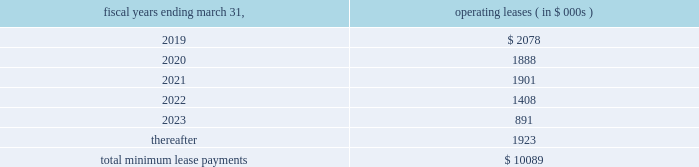Note 11 .
Commitments and contingencies commitments leases the company fffds corporate headquarters is located in danvers , massachusetts .
This facility encompasses most of the company fffds u.s .
Operations , including research and development , manufacturing , sales and marketing and general and administrative departments .
In october 2017 , the acquired its corporate headquarters for approximately $ 16.5 million and terminated its existing lease arrangement ( see note 6 ) .
Future minimum lease payments under non-cancelable leases as of march 31 , 2018 are approximately as follows : fiscal years ending march 31 , operating leases ( in $ 000s ) .
In february 2017 , the company entered into a lease agreement for an additional 21603 square feet of office space in danvers , massachusetts which expires on july 31 , 2022 .
In december 2017 , the company entered into an amendment to this lease to extend the term through august 31 , 2025 and to add an additional 6607 square feet of space in which rent would begin around june 1 , 2018 .
The amendment also allows the company a right of first offer to purchase the property from january 1 , 2018 through august 31 , 2035 , if the lessor decides to sell the building or receives an offer to purchase the building from a third-party buyer .
In march 2018 , the company entered into an amendment to the lease to add an additional 11269 square feet of space for which rent will begin on or around june 1 , 2018 through august 31 , 2025 .
The annual rent expense for this lease agreement is estimated to be $ 0.4 million .
In september 2016 , the company entered into a lease agreement in berlin , germany which commenced in may 2017 and expires in may 2024 .
The annual rent expense for the lease is estimated to be $ 0.3 million .
In october 2016 , the company entered into a lease agreement for an office in tokyokk japan and expires in september 2021 .
The office houses administrative , regulatory , and training personnel in connection with the company fffds commercial launch in japan .
The annual rent expense for the lease is estimated to be $ 0.9 million .
License agreements in april 2014 , the company entered into an exclusive license agreement for the rights to certain optical sensor technologies in the field of cardio-circulatory assist devices .
Pursuant to the terms of the license agreement , the company agreed to make potential payments of $ 6.0 million .
Through march 31 , 2018 , the company has made $ 3.5 million in milestones payments which included a $ 1.5 million upfront payment upon the execution of the agreement .
Any potential future milestone payment amounts have not been included in the contractual obligations table above due to the uncertainty related to the successful achievement of these milestones .
Contingencies from time to time , the company is involved in legal and administrative proceedings and claims of various types .
In some actions , the claimants seek damages , as well as other relief , which , if granted , would require significant expenditures .
The company records a liability in its consolidated financial statements for these matters when a loss is known or considered probable and the amount can be reasonably estimated .
The company reviews these estimates each accounting period as additional information is known and adjusts the loss provision when appropriate .
If a matter is both probable to result in liability and the amount of loss can be reasonably estimated , the company estimates and discloses the possible loss or range of loss .
If the loss is not probable or cannot be reasonably estimated , a liability is not recorded in its consolidated financial statements. .
What is the expected growth rate in operating leases from 2019 to 2020? 
Computations: ((1888 - 2078) / 2078)
Answer: -0.09143. 